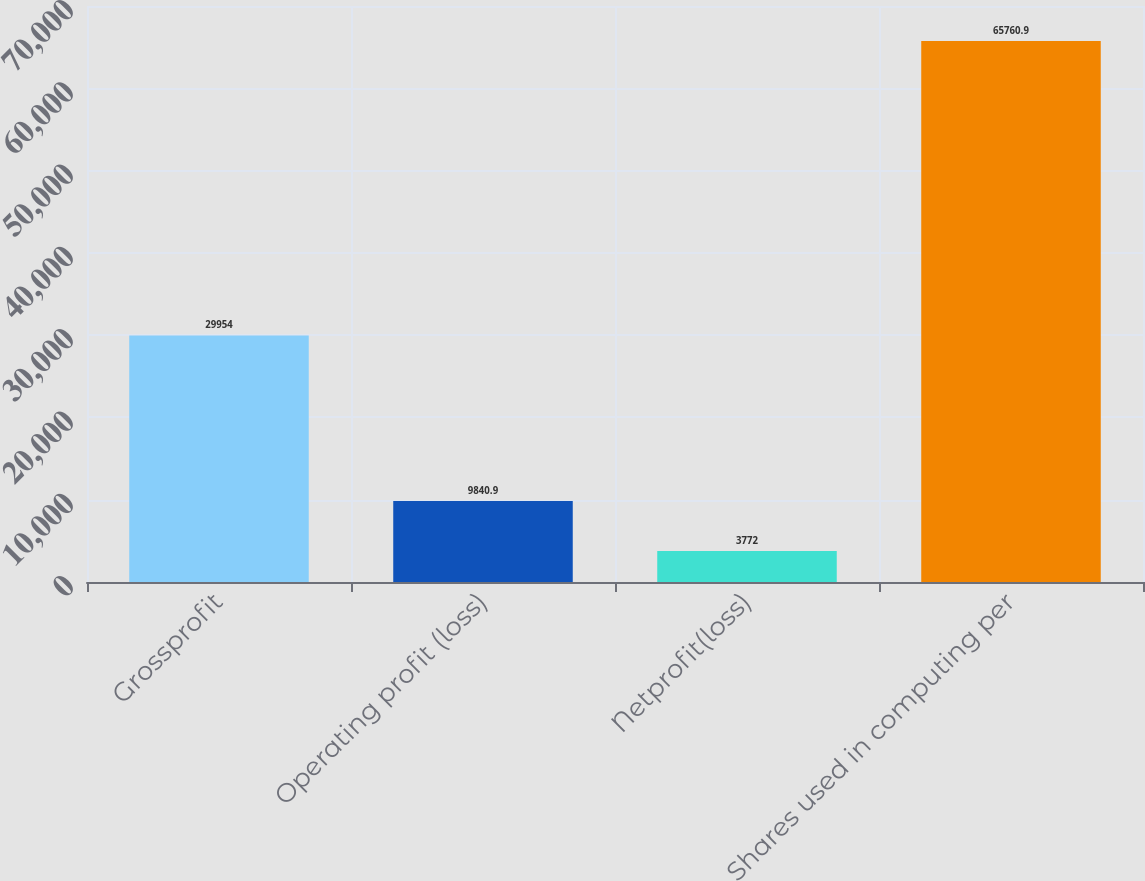Convert chart to OTSL. <chart><loc_0><loc_0><loc_500><loc_500><bar_chart><fcel>Grossprofit<fcel>Operating profit (loss)<fcel>Netprofit(loss)<fcel>Shares used in computing per<nl><fcel>29954<fcel>9840.9<fcel>3772<fcel>65760.9<nl></chart> 